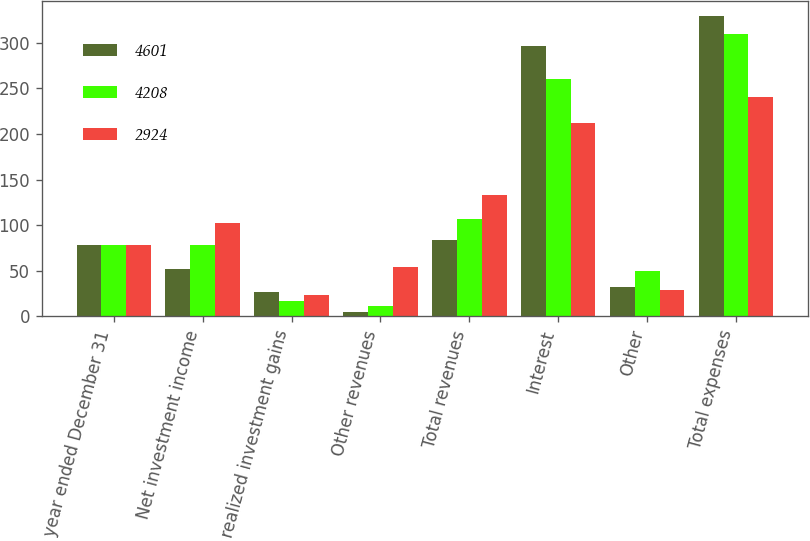Convert chart. <chart><loc_0><loc_0><loc_500><loc_500><stacked_bar_chart><ecel><fcel>For the year ended December 31<fcel>Net investment income<fcel>Net realized investment gains<fcel>Other revenues<fcel>Total revenues<fcel>Interest<fcel>Other<fcel>Total expenses<nl><fcel>4601<fcel>78<fcel>52<fcel>27<fcel>5<fcel>84<fcel>297<fcel>32<fcel>329<nl><fcel>4208<fcel>78<fcel>78<fcel>17<fcel>12<fcel>107<fcel>260<fcel>50<fcel>310<nl><fcel>2924<fcel>78<fcel>103<fcel>24<fcel>54<fcel>133<fcel>212<fcel>29<fcel>241<nl></chart> 